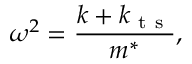Convert formula to latex. <formula><loc_0><loc_0><loc_500><loc_500>\omega ^ { 2 } = \frac { k + k _ { t s } } { m ^ { * } } ,</formula> 